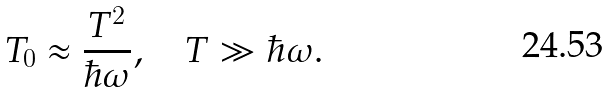<formula> <loc_0><loc_0><loc_500><loc_500>T _ { 0 } \approx \frac { T ^ { 2 } } { \hbar { \omega } } , \quad T \gg \hbar { \omega } .</formula> 